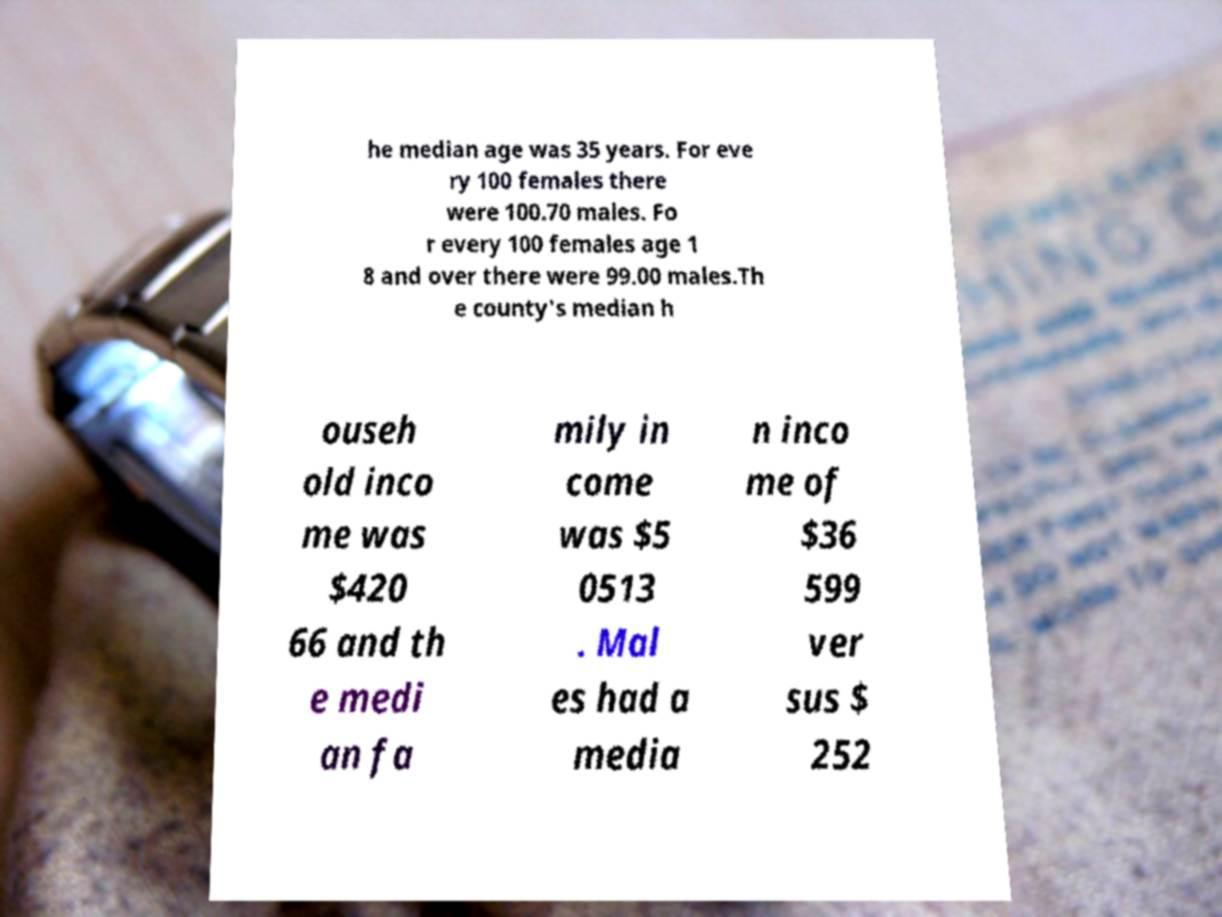Can you accurately transcribe the text from the provided image for me? he median age was 35 years. For eve ry 100 females there were 100.70 males. Fo r every 100 females age 1 8 and over there were 99.00 males.Th e county's median h ouseh old inco me was $420 66 and th e medi an fa mily in come was $5 0513 . Mal es had a media n inco me of $36 599 ver sus $ 252 